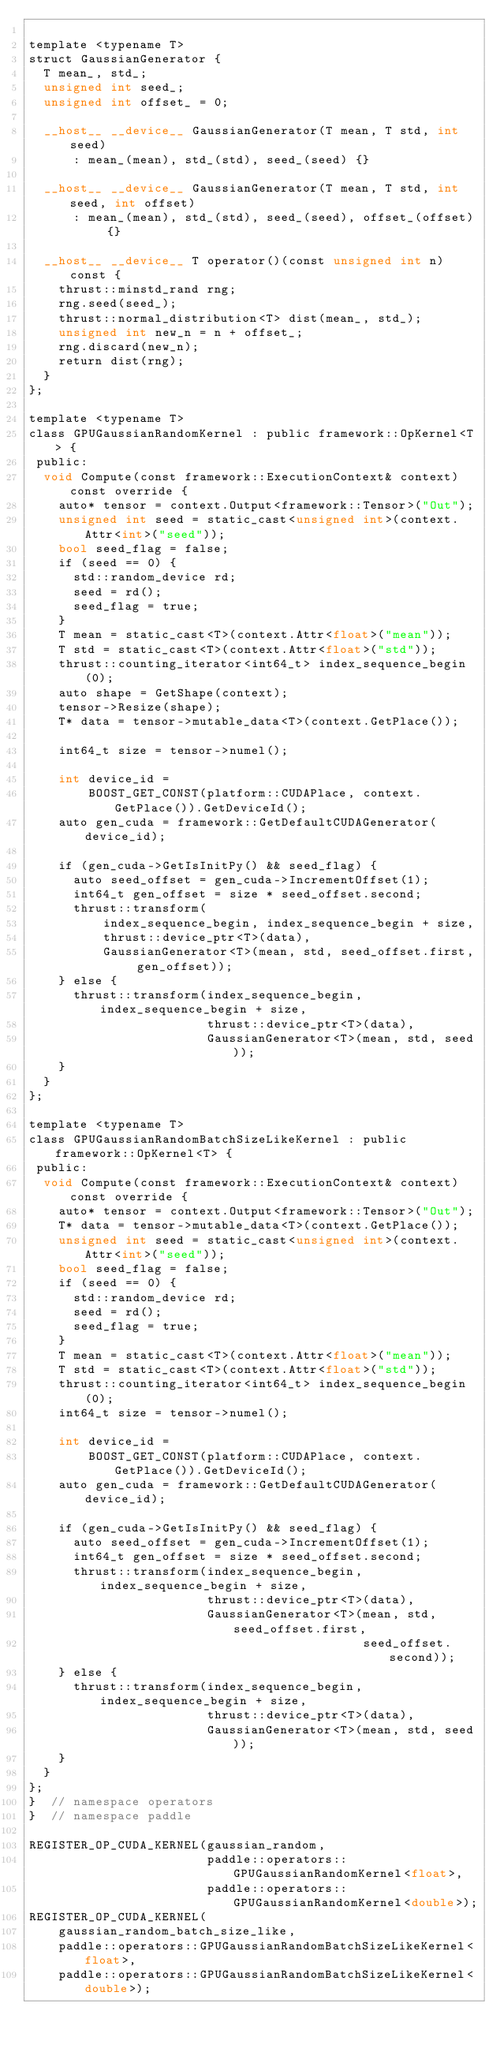Convert code to text. <code><loc_0><loc_0><loc_500><loc_500><_Cuda_>
template <typename T>
struct GaussianGenerator {
  T mean_, std_;
  unsigned int seed_;
  unsigned int offset_ = 0;

  __host__ __device__ GaussianGenerator(T mean, T std, int seed)
      : mean_(mean), std_(std), seed_(seed) {}

  __host__ __device__ GaussianGenerator(T mean, T std, int seed, int offset)
      : mean_(mean), std_(std), seed_(seed), offset_(offset) {}

  __host__ __device__ T operator()(const unsigned int n) const {
    thrust::minstd_rand rng;
    rng.seed(seed_);
    thrust::normal_distribution<T> dist(mean_, std_);
    unsigned int new_n = n + offset_;
    rng.discard(new_n);
    return dist(rng);
  }
};

template <typename T>
class GPUGaussianRandomKernel : public framework::OpKernel<T> {
 public:
  void Compute(const framework::ExecutionContext& context) const override {
    auto* tensor = context.Output<framework::Tensor>("Out");
    unsigned int seed = static_cast<unsigned int>(context.Attr<int>("seed"));
    bool seed_flag = false;
    if (seed == 0) {
      std::random_device rd;
      seed = rd();
      seed_flag = true;
    }
    T mean = static_cast<T>(context.Attr<float>("mean"));
    T std = static_cast<T>(context.Attr<float>("std"));
    thrust::counting_iterator<int64_t> index_sequence_begin(0);
    auto shape = GetShape(context);
    tensor->Resize(shape);
    T* data = tensor->mutable_data<T>(context.GetPlace());

    int64_t size = tensor->numel();

    int device_id =
        BOOST_GET_CONST(platform::CUDAPlace, context.GetPlace()).GetDeviceId();
    auto gen_cuda = framework::GetDefaultCUDAGenerator(device_id);

    if (gen_cuda->GetIsInitPy() && seed_flag) {
      auto seed_offset = gen_cuda->IncrementOffset(1);
      int64_t gen_offset = size * seed_offset.second;
      thrust::transform(
          index_sequence_begin, index_sequence_begin + size,
          thrust::device_ptr<T>(data),
          GaussianGenerator<T>(mean, std, seed_offset.first, gen_offset));
    } else {
      thrust::transform(index_sequence_begin, index_sequence_begin + size,
                        thrust::device_ptr<T>(data),
                        GaussianGenerator<T>(mean, std, seed));
    }
  }
};

template <typename T>
class GPUGaussianRandomBatchSizeLikeKernel : public framework::OpKernel<T> {
 public:
  void Compute(const framework::ExecutionContext& context) const override {
    auto* tensor = context.Output<framework::Tensor>("Out");
    T* data = tensor->mutable_data<T>(context.GetPlace());
    unsigned int seed = static_cast<unsigned int>(context.Attr<int>("seed"));
    bool seed_flag = false;
    if (seed == 0) {
      std::random_device rd;
      seed = rd();
      seed_flag = true;
    }
    T mean = static_cast<T>(context.Attr<float>("mean"));
    T std = static_cast<T>(context.Attr<float>("std"));
    thrust::counting_iterator<int64_t> index_sequence_begin(0);
    int64_t size = tensor->numel();

    int device_id =
        BOOST_GET_CONST(platform::CUDAPlace, context.GetPlace()).GetDeviceId();
    auto gen_cuda = framework::GetDefaultCUDAGenerator(device_id);

    if (gen_cuda->GetIsInitPy() && seed_flag) {
      auto seed_offset = gen_cuda->IncrementOffset(1);
      int64_t gen_offset = size * seed_offset.second;
      thrust::transform(index_sequence_begin, index_sequence_begin + size,
                        thrust::device_ptr<T>(data),
                        GaussianGenerator<T>(mean, std, seed_offset.first,
                                             seed_offset.second));
    } else {
      thrust::transform(index_sequence_begin, index_sequence_begin + size,
                        thrust::device_ptr<T>(data),
                        GaussianGenerator<T>(mean, std, seed));
    }
  }
};
}  // namespace operators
}  // namespace paddle

REGISTER_OP_CUDA_KERNEL(gaussian_random,
                        paddle::operators::GPUGaussianRandomKernel<float>,
                        paddle::operators::GPUGaussianRandomKernel<double>);
REGISTER_OP_CUDA_KERNEL(
    gaussian_random_batch_size_like,
    paddle::operators::GPUGaussianRandomBatchSizeLikeKernel<float>,
    paddle::operators::GPUGaussianRandomBatchSizeLikeKernel<double>);
</code> 